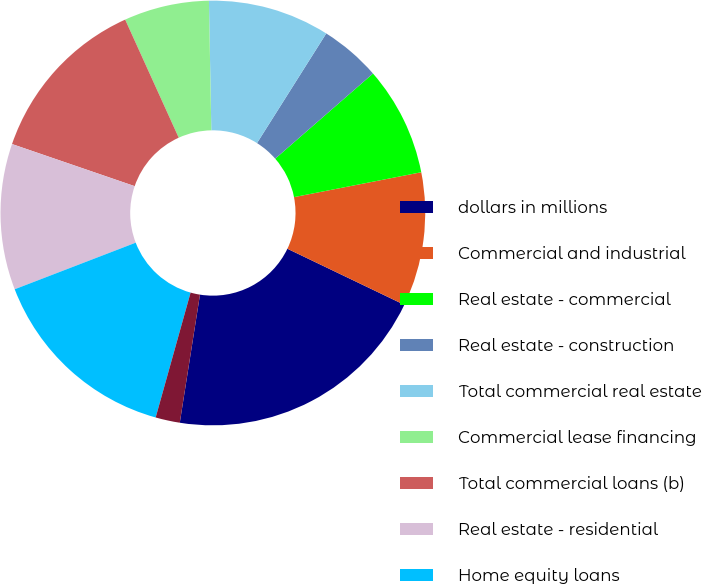Convert chart to OTSL. <chart><loc_0><loc_0><loc_500><loc_500><pie_chart><fcel>dollars in millions<fcel>Commercial and industrial<fcel>Real estate - commercial<fcel>Real estate - construction<fcel>Total commercial real estate<fcel>Commercial lease financing<fcel>Total commercial loans (b)<fcel>Real estate - residential<fcel>Home equity loans<fcel>Consumer direct loans<nl><fcel>20.37%<fcel>10.19%<fcel>8.33%<fcel>4.63%<fcel>9.26%<fcel>6.48%<fcel>12.96%<fcel>11.11%<fcel>14.81%<fcel>1.85%<nl></chart> 